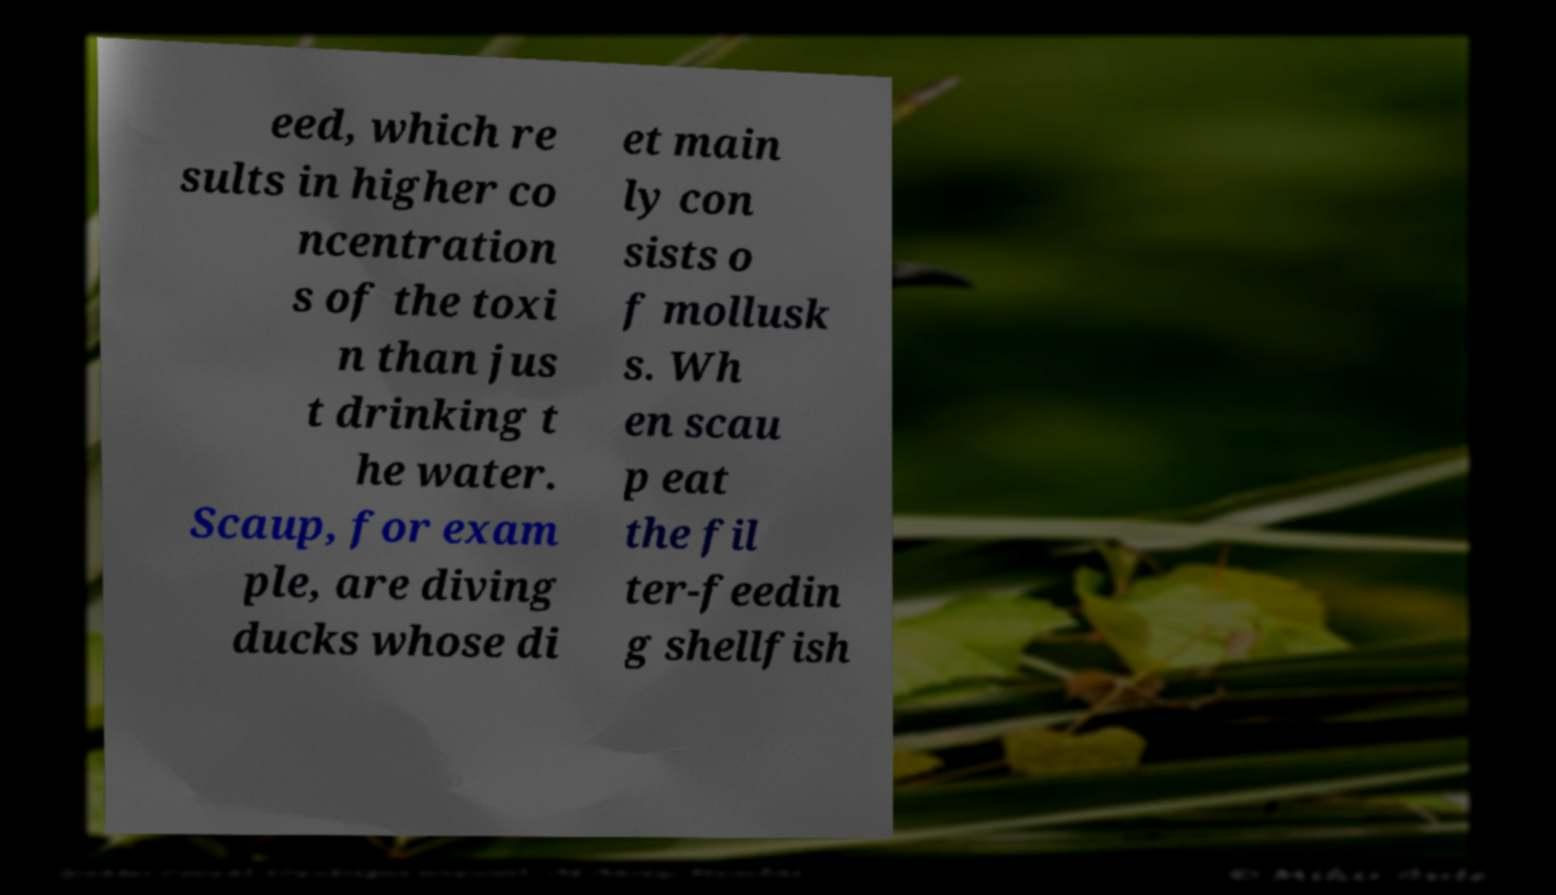I need the written content from this picture converted into text. Can you do that? eed, which re sults in higher co ncentration s of the toxi n than jus t drinking t he water. Scaup, for exam ple, are diving ducks whose di et main ly con sists o f mollusk s. Wh en scau p eat the fil ter-feedin g shellfish 